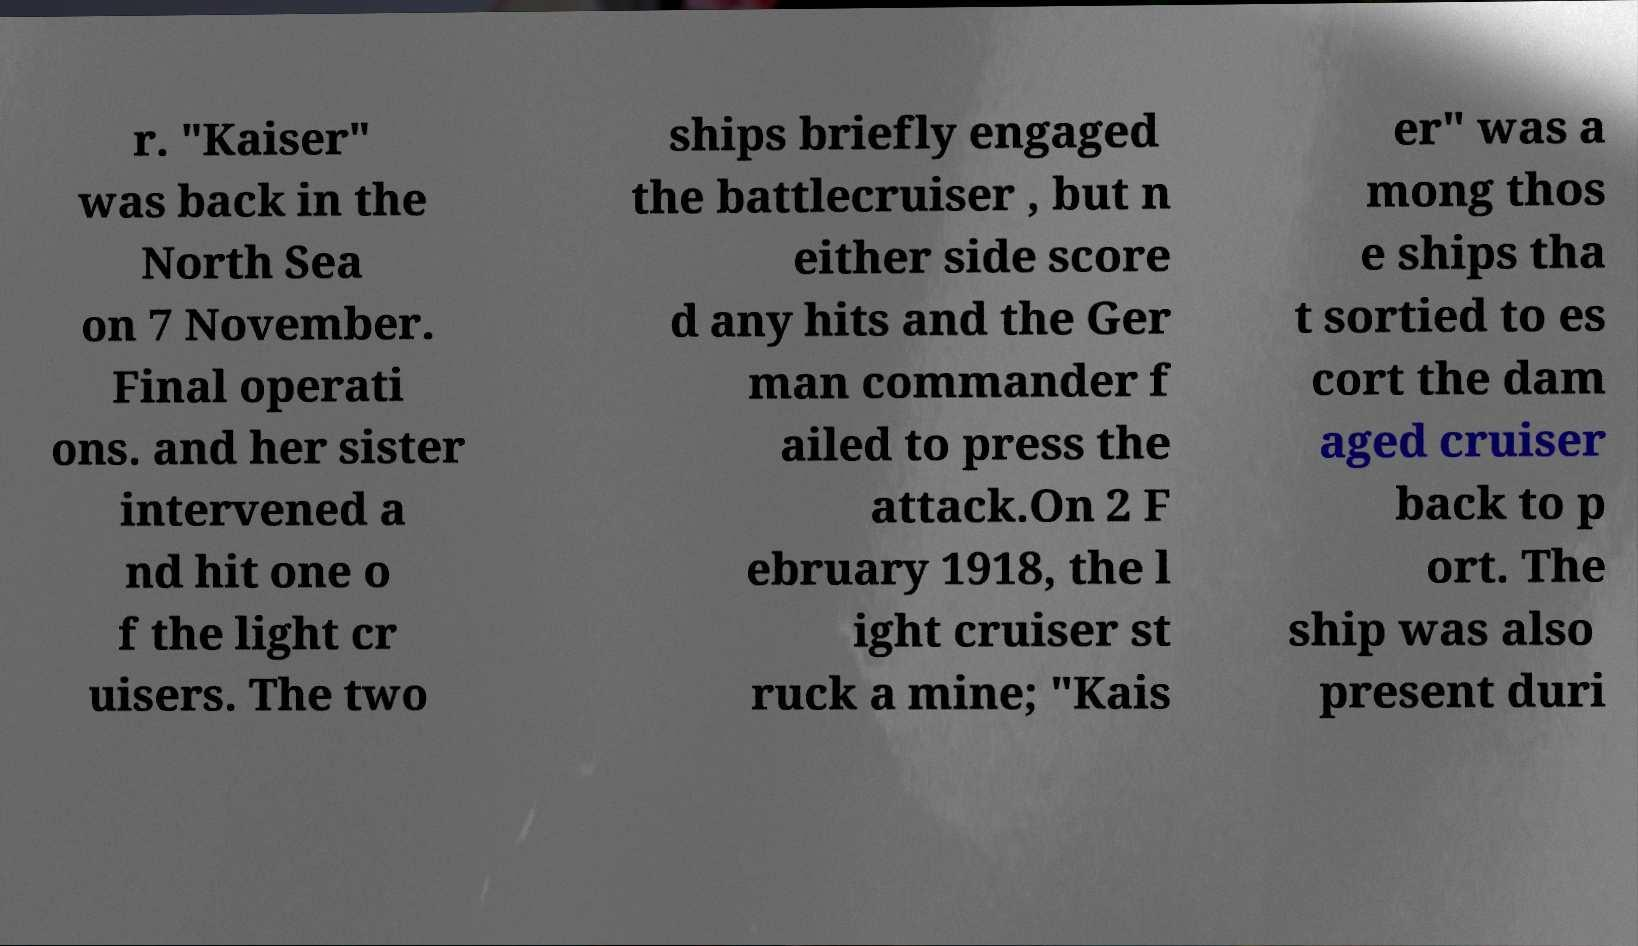Can you accurately transcribe the text from the provided image for me? r. "Kaiser" was back in the North Sea on 7 November. Final operati ons. and her sister intervened a nd hit one o f the light cr uisers. The two ships briefly engaged the battlecruiser , but n either side score d any hits and the Ger man commander f ailed to press the attack.On 2 F ebruary 1918, the l ight cruiser st ruck a mine; "Kais er" was a mong thos e ships tha t sortied to es cort the dam aged cruiser back to p ort. The ship was also present duri 